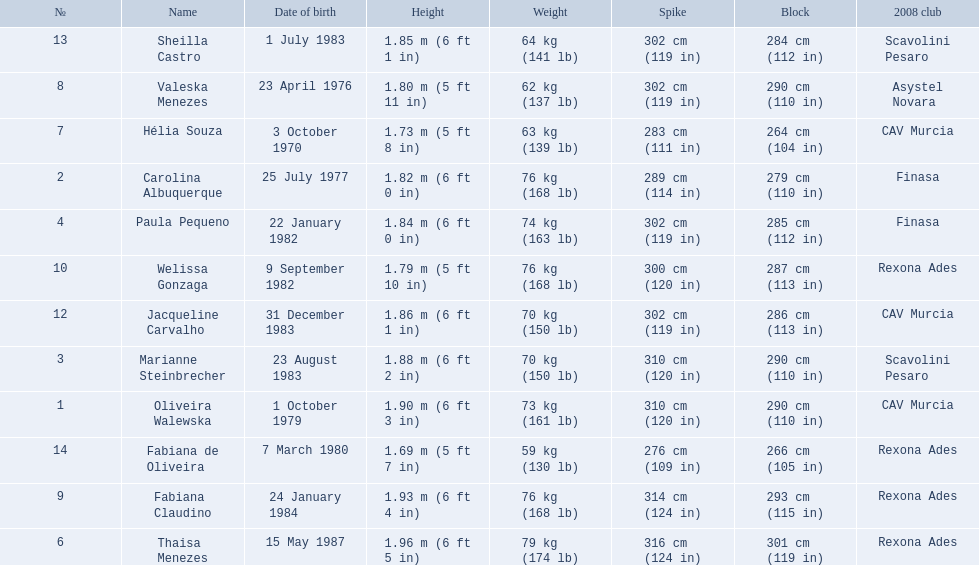Who are the players for brazil at the 2008 summer olympics? Oliveira Walewska, Carolina Albuquerque, Marianne Steinbrecher, Paula Pequeno, Thaisa Menezes, Hélia Souza, Valeska Menezes, Fabiana Claudino, Welissa Gonzaga, Jacqueline Carvalho, Sheilla Castro, Fabiana de Oliveira. What are their heights? 1.90 m (6 ft 3 in), 1.82 m (6 ft 0 in), 1.88 m (6 ft 2 in), 1.84 m (6 ft 0 in), 1.96 m (6 ft 5 in), 1.73 m (5 ft 8 in), 1.80 m (5 ft 11 in), 1.93 m (6 ft 4 in), 1.79 m (5 ft 10 in), 1.86 m (6 ft 1 in), 1.85 m (6 ft 1 in), 1.69 m (5 ft 7 in). What is the shortest height? 1.69 m (5 ft 7 in). Which player is that? Fabiana de Oliveira. 